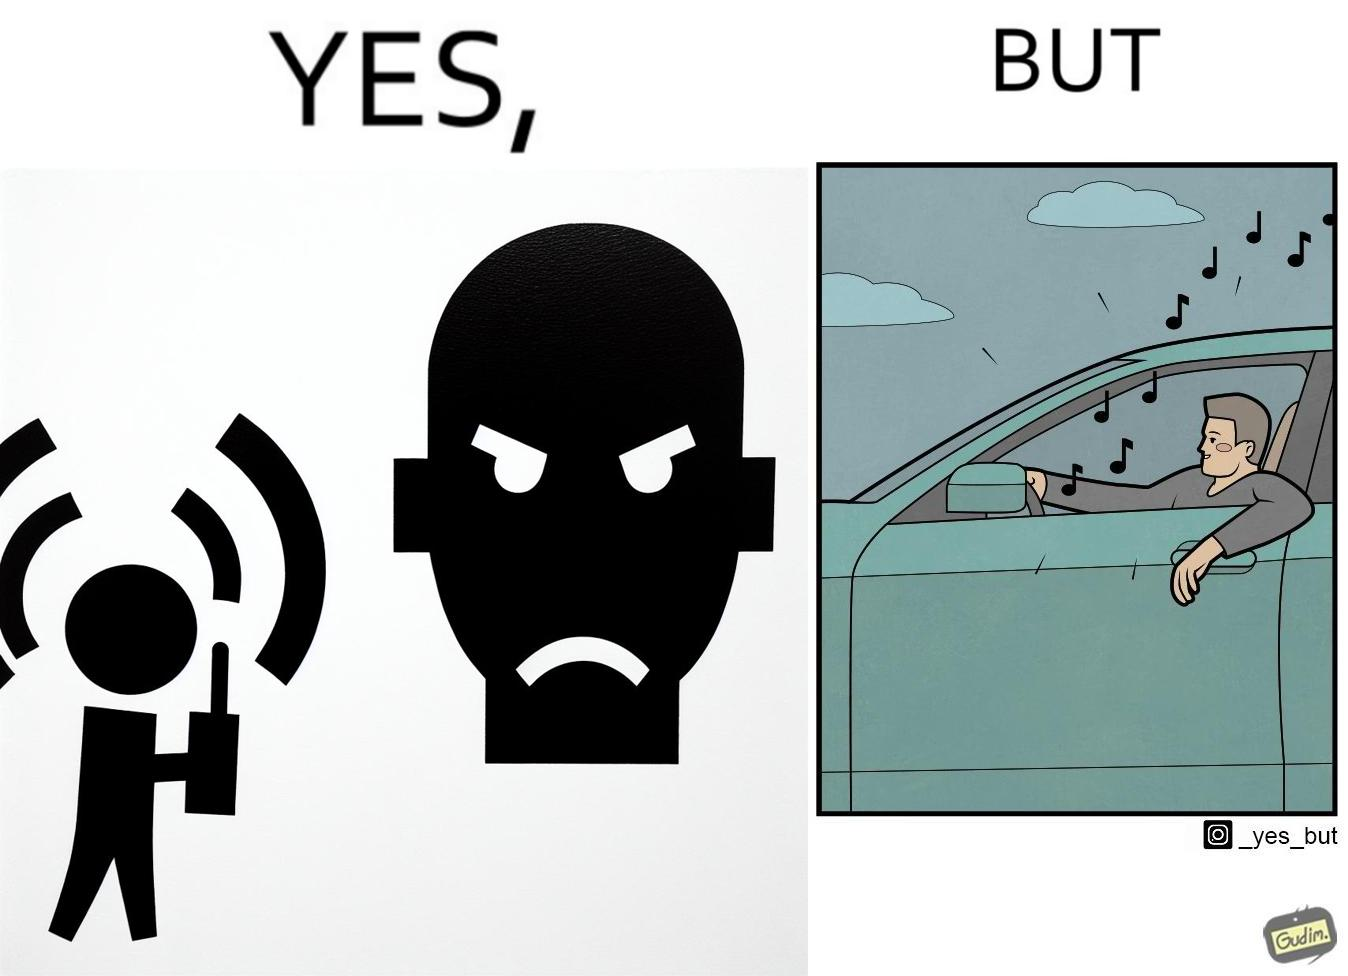Why is this image considered satirical? The image is funny because while the man does not like the boy playing music loudly on his phone, the man himself is okay with doing the same thing with his car and playing loud music in the car with the sound coming out of the car. 